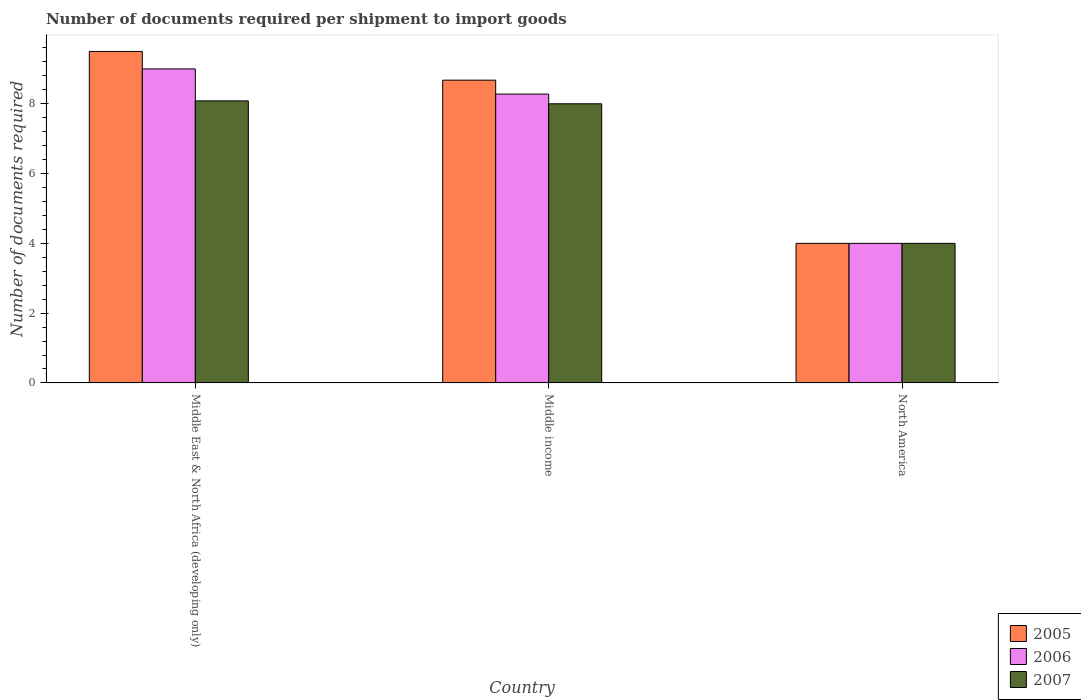How many different coloured bars are there?
Ensure brevity in your answer.  3. Are the number of bars per tick equal to the number of legend labels?
Provide a succinct answer. Yes. How many bars are there on the 3rd tick from the left?
Give a very brief answer. 3. How many bars are there on the 3rd tick from the right?
Offer a very short reply. 3. What is the label of the 1st group of bars from the left?
Keep it short and to the point. Middle East & North Africa (developing only). In how many cases, is the number of bars for a given country not equal to the number of legend labels?
Keep it short and to the point. 0. What is the number of documents required per shipment to import goods in 2006 in Middle East & North Africa (developing only)?
Provide a short and direct response. 9. Across all countries, what is the maximum number of documents required per shipment to import goods in 2007?
Offer a very short reply. 8.08. Across all countries, what is the minimum number of documents required per shipment to import goods in 2006?
Provide a short and direct response. 4. In which country was the number of documents required per shipment to import goods in 2005 maximum?
Ensure brevity in your answer.  Middle East & North Africa (developing only). What is the total number of documents required per shipment to import goods in 2005 in the graph?
Provide a short and direct response. 22.18. What is the difference between the number of documents required per shipment to import goods in 2005 in Middle East & North Africa (developing only) and that in Middle income?
Provide a succinct answer. 0.82. What is the difference between the number of documents required per shipment to import goods in 2005 in Middle East & North Africa (developing only) and the number of documents required per shipment to import goods in 2006 in North America?
Your response must be concise. 5.5. What is the average number of documents required per shipment to import goods in 2006 per country?
Your answer should be very brief. 7.09. What is the difference between the number of documents required per shipment to import goods of/in 2007 and number of documents required per shipment to import goods of/in 2006 in Middle East & North Africa (developing only)?
Give a very brief answer. -0.92. In how many countries, is the number of documents required per shipment to import goods in 2006 greater than 3.2?
Ensure brevity in your answer.  3. What is the ratio of the number of documents required per shipment to import goods in 2006 in Middle East & North Africa (developing only) to that in North America?
Provide a succinct answer. 2.25. Is the difference between the number of documents required per shipment to import goods in 2007 in Middle East & North Africa (developing only) and Middle income greater than the difference between the number of documents required per shipment to import goods in 2006 in Middle East & North Africa (developing only) and Middle income?
Give a very brief answer. No. What is the difference between the highest and the second highest number of documents required per shipment to import goods in 2007?
Your answer should be very brief. 0.08. Are all the bars in the graph horizontal?
Offer a terse response. No. How many countries are there in the graph?
Offer a terse response. 3. What is the difference between two consecutive major ticks on the Y-axis?
Offer a very short reply. 2. Are the values on the major ticks of Y-axis written in scientific E-notation?
Ensure brevity in your answer.  No. Does the graph contain grids?
Offer a very short reply. No. Where does the legend appear in the graph?
Your response must be concise. Bottom right. What is the title of the graph?
Offer a terse response. Number of documents required per shipment to import goods. What is the label or title of the X-axis?
Your response must be concise. Country. What is the label or title of the Y-axis?
Make the answer very short. Number of documents required. What is the Number of documents required of 2006 in Middle East & North Africa (developing only)?
Your answer should be compact. 9. What is the Number of documents required in 2007 in Middle East & North Africa (developing only)?
Your response must be concise. 8.08. What is the Number of documents required of 2005 in Middle income?
Keep it short and to the point. 8.68. What is the Number of documents required in 2006 in Middle income?
Your answer should be very brief. 8.28. What is the Number of documents required in 2007 in Middle income?
Keep it short and to the point. 8. What is the Number of documents required of 2005 in North America?
Give a very brief answer. 4. What is the Number of documents required of 2006 in North America?
Ensure brevity in your answer.  4. Across all countries, what is the maximum Number of documents required of 2007?
Provide a succinct answer. 8.08. Across all countries, what is the minimum Number of documents required of 2005?
Keep it short and to the point. 4. Across all countries, what is the minimum Number of documents required of 2006?
Give a very brief answer. 4. What is the total Number of documents required of 2005 in the graph?
Make the answer very short. 22.18. What is the total Number of documents required of 2006 in the graph?
Your response must be concise. 21.28. What is the total Number of documents required in 2007 in the graph?
Offer a terse response. 20.08. What is the difference between the Number of documents required of 2005 in Middle East & North Africa (developing only) and that in Middle income?
Make the answer very short. 0.82. What is the difference between the Number of documents required in 2006 in Middle East & North Africa (developing only) and that in Middle income?
Your answer should be very brief. 0.72. What is the difference between the Number of documents required of 2007 in Middle East & North Africa (developing only) and that in Middle income?
Your response must be concise. 0.08. What is the difference between the Number of documents required in 2007 in Middle East & North Africa (developing only) and that in North America?
Provide a succinct answer. 4.08. What is the difference between the Number of documents required of 2005 in Middle income and that in North America?
Keep it short and to the point. 4.68. What is the difference between the Number of documents required of 2006 in Middle income and that in North America?
Keep it short and to the point. 4.28. What is the difference between the Number of documents required in 2005 in Middle East & North Africa (developing only) and the Number of documents required in 2006 in Middle income?
Offer a terse response. 1.22. What is the difference between the Number of documents required in 2006 in Middle East & North Africa (developing only) and the Number of documents required in 2007 in Middle income?
Give a very brief answer. 1. What is the difference between the Number of documents required of 2005 in Middle East & North Africa (developing only) and the Number of documents required of 2006 in North America?
Provide a short and direct response. 5.5. What is the difference between the Number of documents required of 2005 in Middle income and the Number of documents required of 2006 in North America?
Provide a succinct answer. 4.68. What is the difference between the Number of documents required in 2005 in Middle income and the Number of documents required in 2007 in North America?
Offer a terse response. 4.68. What is the difference between the Number of documents required in 2006 in Middle income and the Number of documents required in 2007 in North America?
Provide a short and direct response. 4.28. What is the average Number of documents required of 2005 per country?
Your answer should be very brief. 7.39. What is the average Number of documents required of 2006 per country?
Ensure brevity in your answer.  7.09. What is the average Number of documents required in 2007 per country?
Your answer should be compact. 6.69. What is the difference between the Number of documents required in 2005 and Number of documents required in 2007 in Middle East & North Africa (developing only)?
Your answer should be very brief. 1.42. What is the difference between the Number of documents required in 2006 and Number of documents required in 2007 in Middle East & North Africa (developing only)?
Your answer should be very brief. 0.92. What is the difference between the Number of documents required in 2005 and Number of documents required in 2006 in Middle income?
Give a very brief answer. 0.4. What is the difference between the Number of documents required in 2005 and Number of documents required in 2007 in Middle income?
Keep it short and to the point. 0.68. What is the difference between the Number of documents required in 2006 and Number of documents required in 2007 in Middle income?
Make the answer very short. 0.28. What is the difference between the Number of documents required in 2005 and Number of documents required in 2006 in North America?
Provide a succinct answer. 0. What is the difference between the Number of documents required in 2005 and Number of documents required in 2007 in North America?
Offer a very short reply. 0. What is the difference between the Number of documents required of 2006 and Number of documents required of 2007 in North America?
Your answer should be compact. 0. What is the ratio of the Number of documents required of 2005 in Middle East & North Africa (developing only) to that in Middle income?
Your answer should be compact. 1.09. What is the ratio of the Number of documents required of 2006 in Middle East & North Africa (developing only) to that in Middle income?
Provide a succinct answer. 1.09. What is the ratio of the Number of documents required of 2007 in Middle East & North Africa (developing only) to that in Middle income?
Make the answer very short. 1.01. What is the ratio of the Number of documents required in 2005 in Middle East & North Africa (developing only) to that in North America?
Your answer should be very brief. 2.38. What is the ratio of the Number of documents required in 2006 in Middle East & North Africa (developing only) to that in North America?
Offer a terse response. 2.25. What is the ratio of the Number of documents required of 2007 in Middle East & North Africa (developing only) to that in North America?
Your answer should be very brief. 2.02. What is the ratio of the Number of documents required in 2005 in Middle income to that in North America?
Your answer should be very brief. 2.17. What is the ratio of the Number of documents required in 2006 in Middle income to that in North America?
Your answer should be very brief. 2.07. What is the difference between the highest and the second highest Number of documents required in 2005?
Ensure brevity in your answer.  0.82. What is the difference between the highest and the second highest Number of documents required in 2006?
Your response must be concise. 0.72. What is the difference between the highest and the second highest Number of documents required in 2007?
Provide a succinct answer. 0.08. What is the difference between the highest and the lowest Number of documents required in 2007?
Offer a very short reply. 4.08. 